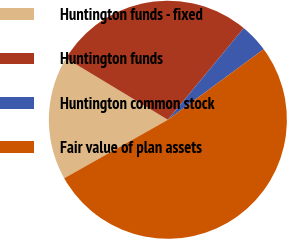<chart> <loc_0><loc_0><loc_500><loc_500><pie_chart><fcel>Huntington funds - fixed<fcel>Huntington funds<fcel>Huntington common stock<fcel>Fair value of plan assets<nl><fcel>16.82%<fcel>27.36%<fcel>3.89%<fcel>51.93%<nl></chart> 